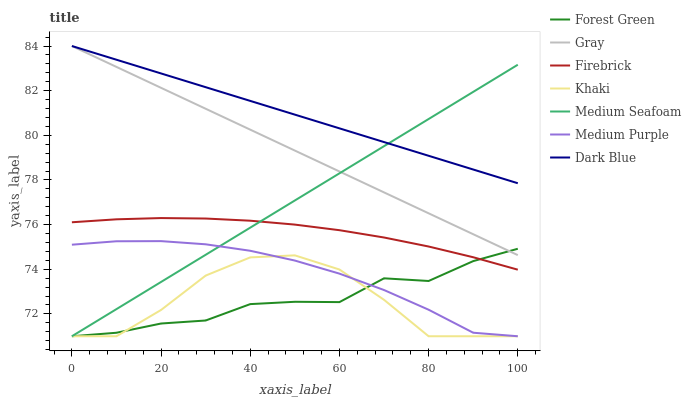Does Khaki have the minimum area under the curve?
Answer yes or no. Yes. Does Dark Blue have the maximum area under the curve?
Answer yes or no. Yes. Does Firebrick have the minimum area under the curve?
Answer yes or no. No. Does Firebrick have the maximum area under the curve?
Answer yes or no. No. Is Dark Blue the smoothest?
Answer yes or no. Yes. Is Khaki the roughest?
Answer yes or no. Yes. Is Firebrick the smoothest?
Answer yes or no. No. Is Firebrick the roughest?
Answer yes or no. No. Does Khaki have the lowest value?
Answer yes or no. Yes. Does Firebrick have the lowest value?
Answer yes or no. No. Does Dark Blue have the highest value?
Answer yes or no. Yes. Does Firebrick have the highest value?
Answer yes or no. No. Is Medium Purple less than Gray?
Answer yes or no. Yes. Is Gray greater than Medium Purple?
Answer yes or no. Yes. Does Medium Purple intersect Forest Green?
Answer yes or no. Yes. Is Medium Purple less than Forest Green?
Answer yes or no. No. Is Medium Purple greater than Forest Green?
Answer yes or no. No. Does Medium Purple intersect Gray?
Answer yes or no. No. 